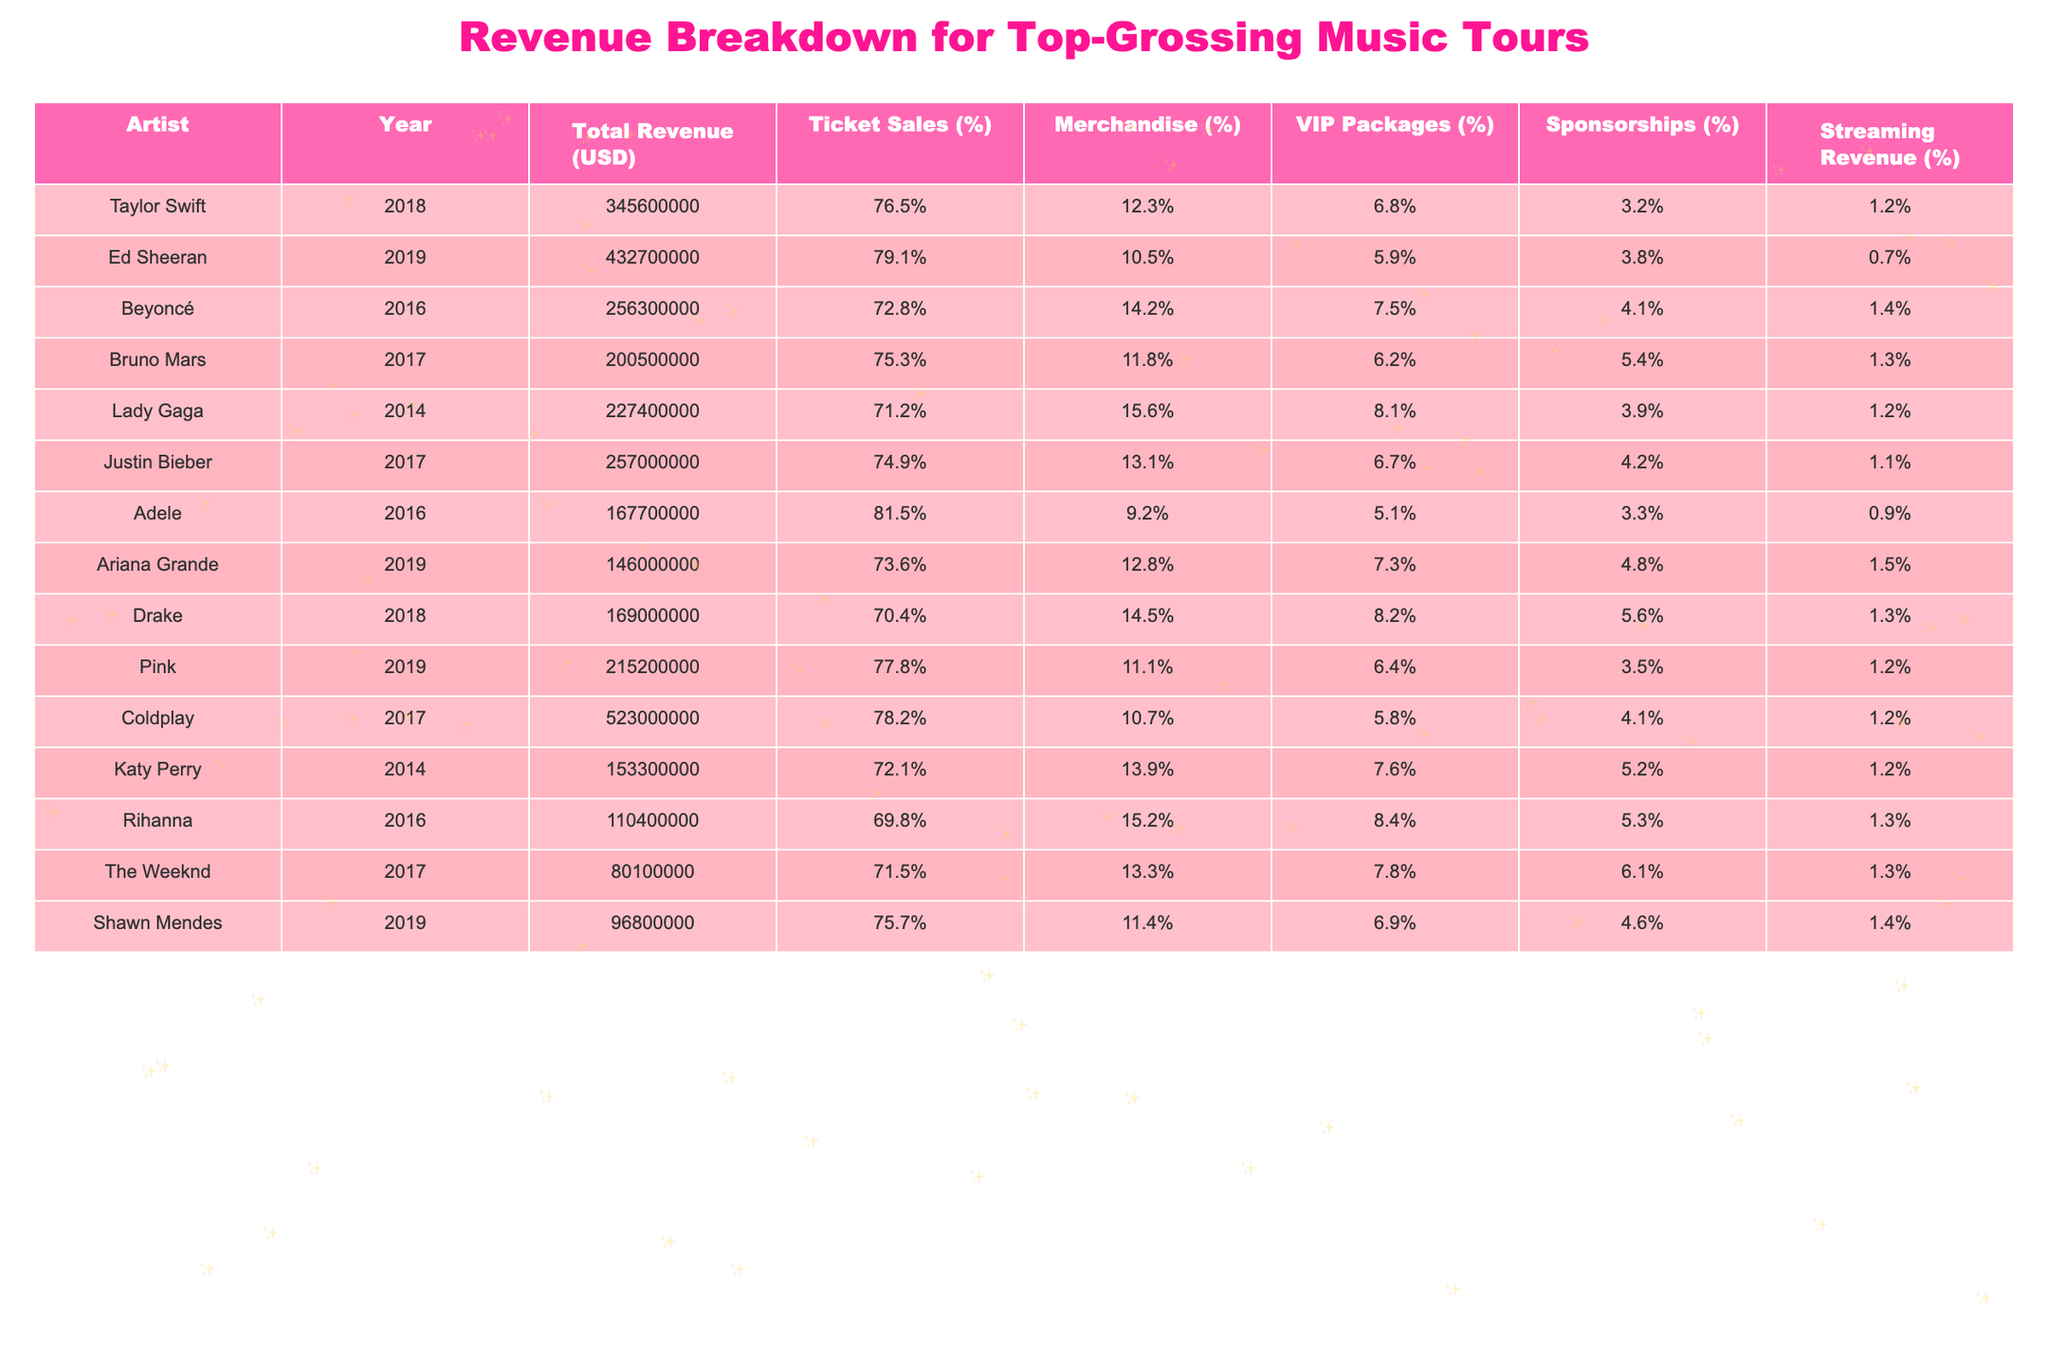What is the total revenue generated by Taylor Swift's tour in 2018? The table states that Taylor Swift's total revenue for the year 2018 is listed as $345,600,000.
Answer: $345,600,000 Which artist had the highest percentage of revenue from ticket sales in their tour? By examining the percentages for ticket sales, Ed Sheeran has the highest at 79.1%.
Answer: Ed Sheeran What is the average revenue from merchandise across all artists in the table? The merchandise percentages are: 12.3, 10.5, 14.2, 11.8, 15.6, 13.1, 9.2, 12.8, 14.5, 11.1, 13.9, 15.2, 13.3, 11.4. The average is calculated as (12.3 + 10.5 + 14.2 + 11.8 + 15.6 + 13.1 + 9.2 + 12.8 + 14.5 + 11.1 + 13.9 + 15.2 + 13.3 + 11.4) / 14 = 12.6%.
Answer: 12.6% Did any artist generate more than $400 million in total revenue? By checking the total revenue figures, only Ed Sheeran's revenue exceeds $400 million, at $432,700,000.
Answer: Yes Which artist had the least revenue from VIP packages and what percentage was it? Looking at the VIP Packages percentages, Shawn Mendes had the least revenue contribution at 6.9%.
Answer: Shawn Mendes, 6.9% If we compare the total revenues of Beyoncé and Drake, who earned more and by how much? Beyoncé earned $256,300,000 and Drake earned $169,000,000. The difference is $256,300,000 - $169,000,000 = $87,300,000.
Answer: Beyoncé, $87,300,000 What is the total percentage of revenue from merchandise for Coldplay in 2017? The table states that Coldplay's revenue from merchandise is 10.7%.
Answer: 10.7% Which artist earned the least total revenue, and what was the amount? The artist with the least total revenue is The Weeknd, with $80,100,000.
Answer: The Weeknd, $80,100,000 If we consider the total revenue of all artists listed, what is the total? Adding all total revenues together: $345,600,000 + $432,700,000 + $256,300,000 + $200,500,000 + $227,400,000 + $257,000,000 + $167,700,000 + $146,000,000 + $169,000,000 + $215,200,000 + $153,300,000 + $110,400,000 + $80,100,000 + $96,800,000 = $2,388,400,000.
Answer: $2,388,400,000 Which artist had a higher percentage from sponsorships: Pink or Justin Bieber? Pink had 3.5% from sponsorships, while Justin Bieber had 4.2%, indicating Justin Bieber had the higher percentage.
Answer: Justin Bieber Is the percentage of revenue from streaming higher for Lady Gaga compared to Adele? Lady Gaga had 1.2% from streaming while Adele had 0.9%. Since 1.2% is greater than 0.9%, the answer is yes.
Answer: Yes 